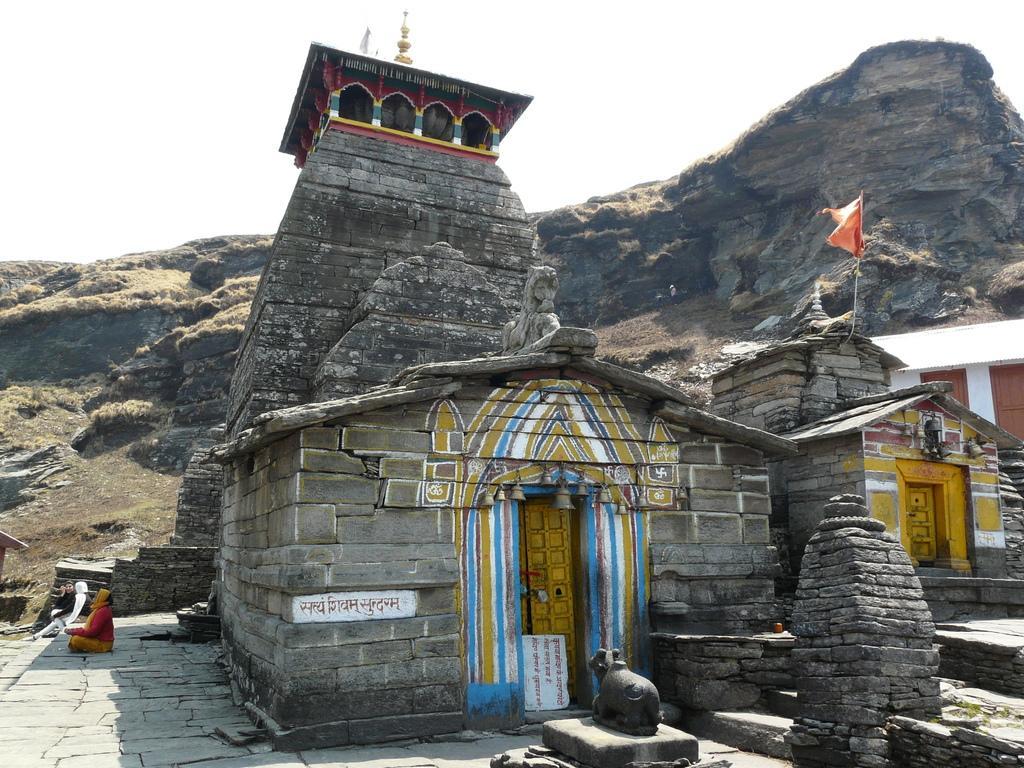Can you describe this image briefly? In this image, we can see some temples and rock hills. We can see the ground and a statue. We can see a flag and a few people. We can also see the sky. 